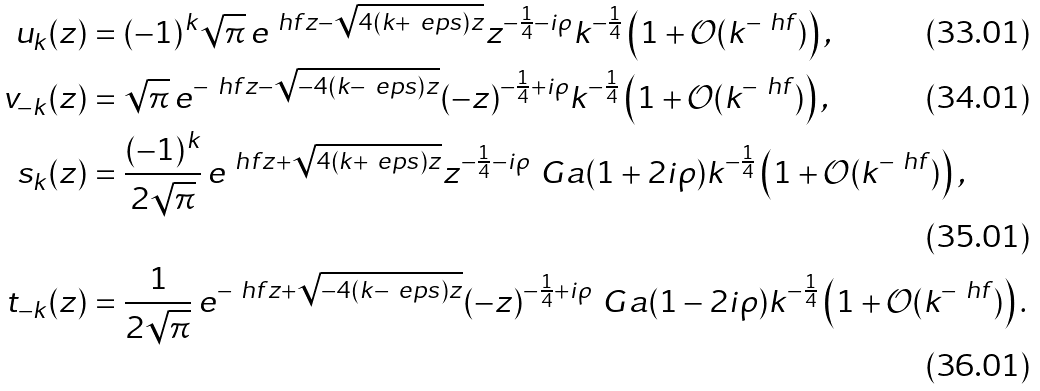Convert formula to latex. <formula><loc_0><loc_0><loc_500><loc_500>u _ { k } ( z ) & = ( - 1 ) ^ { k } \sqrt { \pi } \, e ^ { \ h f z - \sqrt { 4 ( k + \ e p s ) z } } z ^ { - \frac { 1 } { 4 } - i \rho } k ^ { - \frac { 1 } { 4 } } \left ( 1 + \mathcal { O } ( k ^ { - \ h f } ) \right ) , \\ v _ { - k } ( z ) & = \sqrt { \pi } \, e ^ { - \ h f z - \sqrt { - 4 ( k - \ e p s ) z } } ( - z ) ^ { - \frac { 1 } { 4 } + i \rho } k ^ { - \frac { 1 } { 4 } } \left ( 1 + \mathcal { O } ( k ^ { - \ h f } ) \right ) , \\ s _ { k } ( z ) & = \frac { ( - 1 ) ^ { k } } { 2 \sqrt { \pi } } \, e ^ { \ h f z + \sqrt { 4 ( k + \ e p s ) z } } z ^ { - \frac { 1 } { 4 } - i \rho } \ G a ( 1 + 2 i \rho ) k ^ { - \frac { 1 } { 4 } } \left ( 1 + \mathcal { O } ( k ^ { - \ h f } ) \right ) , \\ t _ { - k } ( z ) & = \frac { 1 } { 2 \sqrt { \pi } } \, e ^ { - \ h f z + \sqrt { - 4 ( k - \ e p s ) z } } ( - z ) ^ { - \frac { 1 } { 4 } + i \rho } \ G a ( 1 - 2 i \rho ) k ^ { - \frac { 1 } { 4 } } \left ( 1 + \mathcal { O } ( k ^ { - \ h f } ) \right ) .</formula> 